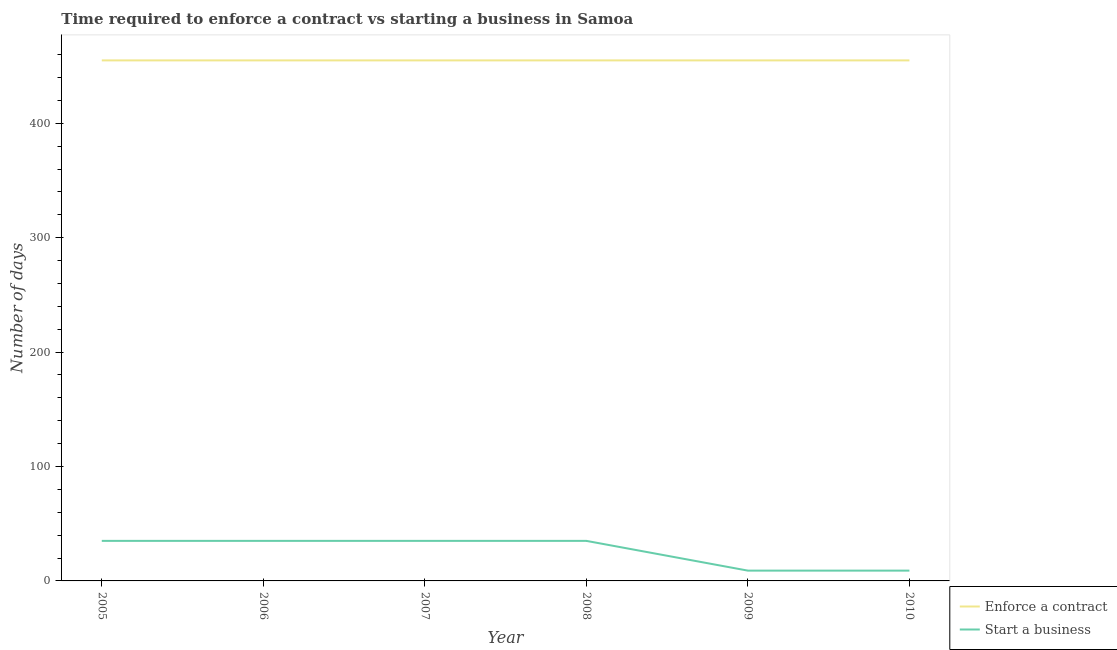What is the number of days to start a business in 2008?
Provide a short and direct response. 35. Across all years, what is the maximum number of days to enforece a contract?
Keep it short and to the point. 455. Across all years, what is the minimum number of days to enforece a contract?
Provide a short and direct response. 455. In which year was the number of days to enforece a contract maximum?
Keep it short and to the point. 2005. What is the total number of days to enforece a contract in the graph?
Keep it short and to the point. 2730. What is the difference between the number of days to enforece a contract in 2005 and that in 2007?
Your answer should be very brief. 0. What is the difference between the number of days to start a business in 2005 and the number of days to enforece a contract in 2008?
Provide a succinct answer. -420. What is the average number of days to start a business per year?
Offer a terse response. 26.33. In the year 2005, what is the difference between the number of days to enforece a contract and number of days to start a business?
Provide a short and direct response. 420. In how many years, is the number of days to start a business greater than 380 days?
Make the answer very short. 0. What is the ratio of the number of days to start a business in 2007 to that in 2010?
Ensure brevity in your answer.  3.89. Is the number of days to enforece a contract in 2005 less than that in 2008?
Give a very brief answer. No. What is the difference between the highest and the lowest number of days to enforece a contract?
Your response must be concise. 0. In how many years, is the number of days to start a business greater than the average number of days to start a business taken over all years?
Ensure brevity in your answer.  4. Does the number of days to enforece a contract monotonically increase over the years?
Keep it short and to the point. No. Is the number of days to start a business strictly less than the number of days to enforece a contract over the years?
Give a very brief answer. Yes. Are the values on the major ticks of Y-axis written in scientific E-notation?
Ensure brevity in your answer.  No. Does the graph contain grids?
Your answer should be very brief. No. How are the legend labels stacked?
Your answer should be compact. Vertical. What is the title of the graph?
Provide a short and direct response. Time required to enforce a contract vs starting a business in Samoa. Does "constant 2005 US$" appear as one of the legend labels in the graph?
Offer a terse response. No. What is the label or title of the X-axis?
Ensure brevity in your answer.  Year. What is the label or title of the Y-axis?
Provide a succinct answer. Number of days. What is the Number of days of Enforce a contract in 2005?
Offer a terse response. 455. What is the Number of days in Enforce a contract in 2006?
Your answer should be very brief. 455. What is the Number of days of Start a business in 2006?
Your answer should be very brief. 35. What is the Number of days of Enforce a contract in 2007?
Offer a terse response. 455. What is the Number of days of Start a business in 2007?
Offer a very short reply. 35. What is the Number of days of Enforce a contract in 2008?
Keep it short and to the point. 455. What is the Number of days in Start a business in 2008?
Your response must be concise. 35. What is the Number of days in Enforce a contract in 2009?
Provide a succinct answer. 455. What is the Number of days of Enforce a contract in 2010?
Make the answer very short. 455. Across all years, what is the maximum Number of days in Enforce a contract?
Your answer should be compact. 455. Across all years, what is the maximum Number of days of Start a business?
Provide a short and direct response. 35. Across all years, what is the minimum Number of days in Enforce a contract?
Keep it short and to the point. 455. Across all years, what is the minimum Number of days of Start a business?
Ensure brevity in your answer.  9. What is the total Number of days in Enforce a contract in the graph?
Provide a short and direct response. 2730. What is the total Number of days of Start a business in the graph?
Your response must be concise. 158. What is the difference between the Number of days in Start a business in 2005 and that in 2006?
Your answer should be compact. 0. What is the difference between the Number of days of Enforce a contract in 2005 and that in 2007?
Make the answer very short. 0. What is the difference between the Number of days of Start a business in 2005 and that in 2007?
Make the answer very short. 0. What is the difference between the Number of days in Enforce a contract in 2005 and that in 2010?
Your response must be concise. 0. What is the difference between the Number of days of Start a business in 2005 and that in 2010?
Your answer should be very brief. 26. What is the difference between the Number of days of Enforce a contract in 2006 and that in 2007?
Offer a very short reply. 0. What is the difference between the Number of days of Enforce a contract in 2006 and that in 2008?
Keep it short and to the point. 0. What is the difference between the Number of days in Start a business in 2006 and that in 2009?
Your answer should be compact. 26. What is the difference between the Number of days in Enforce a contract in 2006 and that in 2010?
Give a very brief answer. 0. What is the difference between the Number of days of Enforce a contract in 2007 and that in 2008?
Ensure brevity in your answer.  0. What is the difference between the Number of days in Start a business in 2007 and that in 2008?
Ensure brevity in your answer.  0. What is the difference between the Number of days in Enforce a contract in 2007 and that in 2009?
Make the answer very short. 0. What is the difference between the Number of days of Enforce a contract in 2007 and that in 2010?
Your response must be concise. 0. What is the difference between the Number of days of Start a business in 2008 and that in 2010?
Provide a succinct answer. 26. What is the difference between the Number of days in Enforce a contract in 2005 and the Number of days in Start a business in 2006?
Your response must be concise. 420. What is the difference between the Number of days in Enforce a contract in 2005 and the Number of days in Start a business in 2007?
Make the answer very short. 420. What is the difference between the Number of days in Enforce a contract in 2005 and the Number of days in Start a business in 2008?
Your response must be concise. 420. What is the difference between the Number of days in Enforce a contract in 2005 and the Number of days in Start a business in 2009?
Keep it short and to the point. 446. What is the difference between the Number of days in Enforce a contract in 2005 and the Number of days in Start a business in 2010?
Give a very brief answer. 446. What is the difference between the Number of days of Enforce a contract in 2006 and the Number of days of Start a business in 2007?
Offer a terse response. 420. What is the difference between the Number of days of Enforce a contract in 2006 and the Number of days of Start a business in 2008?
Keep it short and to the point. 420. What is the difference between the Number of days of Enforce a contract in 2006 and the Number of days of Start a business in 2009?
Your answer should be very brief. 446. What is the difference between the Number of days in Enforce a contract in 2006 and the Number of days in Start a business in 2010?
Your response must be concise. 446. What is the difference between the Number of days in Enforce a contract in 2007 and the Number of days in Start a business in 2008?
Your answer should be very brief. 420. What is the difference between the Number of days of Enforce a contract in 2007 and the Number of days of Start a business in 2009?
Provide a short and direct response. 446. What is the difference between the Number of days in Enforce a contract in 2007 and the Number of days in Start a business in 2010?
Your answer should be very brief. 446. What is the difference between the Number of days in Enforce a contract in 2008 and the Number of days in Start a business in 2009?
Ensure brevity in your answer.  446. What is the difference between the Number of days of Enforce a contract in 2008 and the Number of days of Start a business in 2010?
Offer a terse response. 446. What is the difference between the Number of days in Enforce a contract in 2009 and the Number of days in Start a business in 2010?
Provide a succinct answer. 446. What is the average Number of days of Enforce a contract per year?
Make the answer very short. 455. What is the average Number of days of Start a business per year?
Your response must be concise. 26.33. In the year 2005, what is the difference between the Number of days of Enforce a contract and Number of days of Start a business?
Keep it short and to the point. 420. In the year 2006, what is the difference between the Number of days of Enforce a contract and Number of days of Start a business?
Your answer should be compact. 420. In the year 2007, what is the difference between the Number of days in Enforce a contract and Number of days in Start a business?
Your answer should be compact. 420. In the year 2008, what is the difference between the Number of days of Enforce a contract and Number of days of Start a business?
Make the answer very short. 420. In the year 2009, what is the difference between the Number of days of Enforce a contract and Number of days of Start a business?
Your answer should be compact. 446. In the year 2010, what is the difference between the Number of days of Enforce a contract and Number of days of Start a business?
Your answer should be very brief. 446. What is the ratio of the Number of days of Enforce a contract in 2005 to that in 2006?
Ensure brevity in your answer.  1. What is the ratio of the Number of days of Enforce a contract in 2005 to that in 2007?
Your answer should be very brief. 1. What is the ratio of the Number of days in Start a business in 2005 to that in 2007?
Make the answer very short. 1. What is the ratio of the Number of days of Start a business in 2005 to that in 2008?
Your response must be concise. 1. What is the ratio of the Number of days of Enforce a contract in 2005 to that in 2009?
Offer a very short reply. 1. What is the ratio of the Number of days in Start a business in 2005 to that in 2009?
Provide a succinct answer. 3.89. What is the ratio of the Number of days of Start a business in 2005 to that in 2010?
Provide a short and direct response. 3.89. What is the ratio of the Number of days of Enforce a contract in 2006 to that in 2008?
Ensure brevity in your answer.  1. What is the ratio of the Number of days of Enforce a contract in 2006 to that in 2009?
Offer a terse response. 1. What is the ratio of the Number of days in Start a business in 2006 to that in 2009?
Offer a very short reply. 3.89. What is the ratio of the Number of days in Enforce a contract in 2006 to that in 2010?
Your response must be concise. 1. What is the ratio of the Number of days of Start a business in 2006 to that in 2010?
Offer a very short reply. 3.89. What is the ratio of the Number of days in Enforce a contract in 2007 to that in 2008?
Your answer should be very brief. 1. What is the ratio of the Number of days of Start a business in 2007 to that in 2008?
Ensure brevity in your answer.  1. What is the ratio of the Number of days in Enforce a contract in 2007 to that in 2009?
Your answer should be compact. 1. What is the ratio of the Number of days in Start a business in 2007 to that in 2009?
Your answer should be very brief. 3.89. What is the ratio of the Number of days of Start a business in 2007 to that in 2010?
Keep it short and to the point. 3.89. What is the ratio of the Number of days of Enforce a contract in 2008 to that in 2009?
Offer a terse response. 1. What is the ratio of the Number of days of Start a business in 2008 to that in 2009?
Offer a very short reply. 3.89. What is the ratio of the Number of days in Enforce a contract in 2008 to that in 2010?
Ensure brevity in your answer.  1. What is the ratio of the Number of days of Start a business in 2008 to that in 2010?
Your answer should be compact. 3.89. What is the ratio of the Number of days in Start a business in 2009 to that in 2010?
Ensure brevity in your answer.  1. What is the difference between the highest and the second highest Number of days in Start a business?
Provide a short and direct response. 0. What is the difference between the highest and the lowest Number of days in Enforce a contract?
Make the answer very short. 0. What is the difference between the highest and the lowest Number of days of Start a business?
Make the answer very short. 26. 